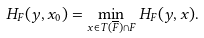Convert formula to latex. <formula><loc_0><loc_0><loc_500><loc_500>H _ { F } ( y , x _ { 0 } ) = \min _ { x \in T ( \overline { F } ) \cap F } H _ { F } ( y , x ) .</formula> 